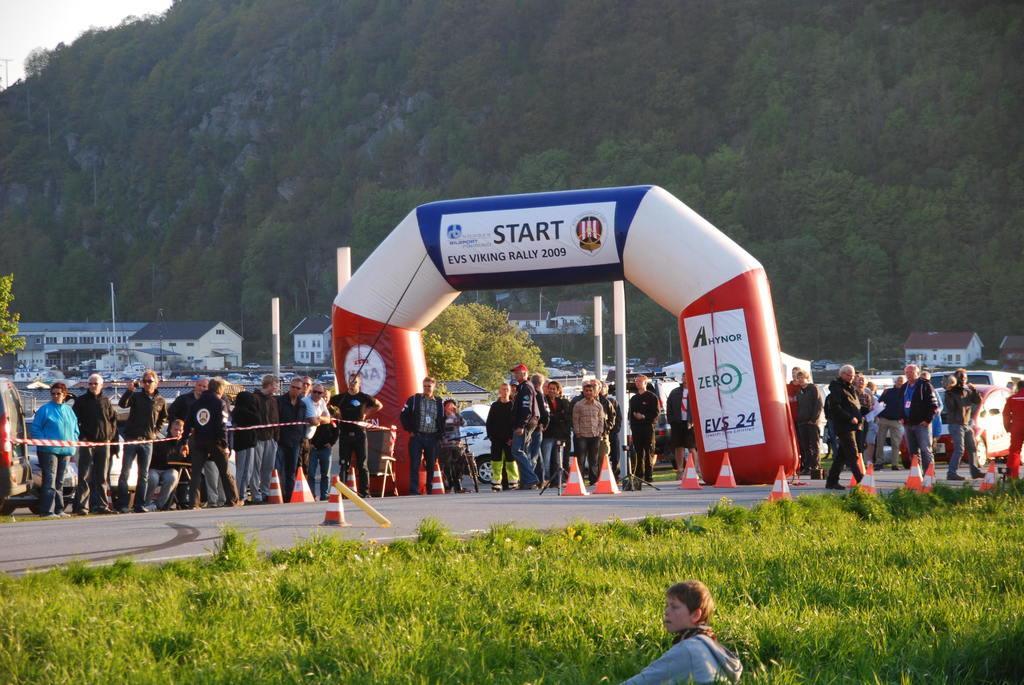Could you give a brief overview of what you see in this image? This image is taken outdoors. In the background there is a hill and there are many trees and plants with leaves, stems and branches. At the top left of the image there is the sky. In the background there are many houses. Few cars are parked on the road. There is a tree. In the middle of the image many people are standing on the road and a few are walking. There are many safety cones on the road. There is an air balloon like an arch. At the bottom of the image there is a ground with grass on it and there is a person. 